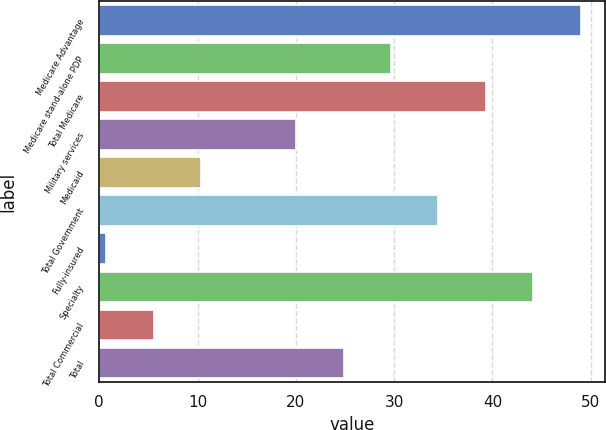Convert chart. <chart><loc_0><loc_0><loc_500><loc_500><bar_chart><fcel>Medicare Advantage<fcel>Medicare stand-alone PDP<fcel>Total Medicare<fcel>Military services<fcel>Medicaid<fcel>Total Government<fcel>Fully-insured<fcel>Specialty<fcel>Total Commercial<fcel>Total<nl><fcel>49<fcel>29.68<fcel>39.34<fcel>20.02<fcel>10.36<fcel>34.51<fcel>0.7<fcel>44.17<fcel>5.53<fcel>24.85<nl></chart> 